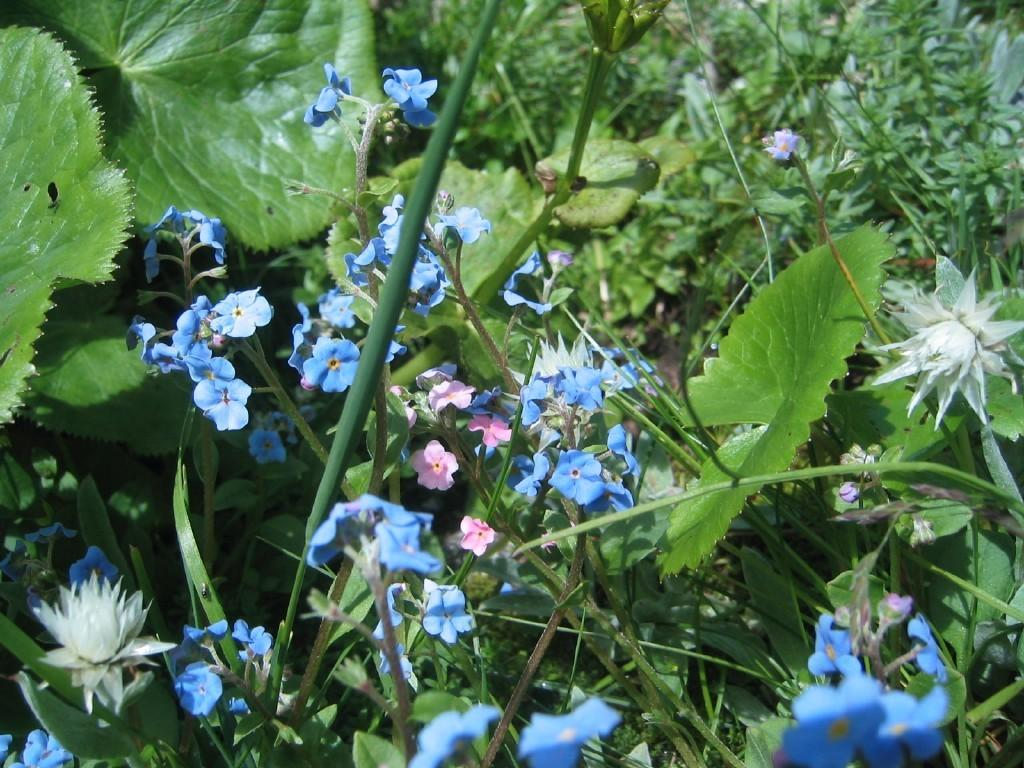What is the main subject of the image? The main subject of the image is flower plants. How many flower plants are there in the image? There are flower plants in the middle of the image. What else can be seen in the image besides the flower plants? There are many plants surrounding the flower plants in the image. What type of quiver is visible in the image? There is no quiver present in the image; it features flower plants and surrounding plants. How does the wealth of the plants in the image compare to the wealth of the plants in the neighboring garden? There is no information about the wealth of the plants or the neighboring garden in the image. 